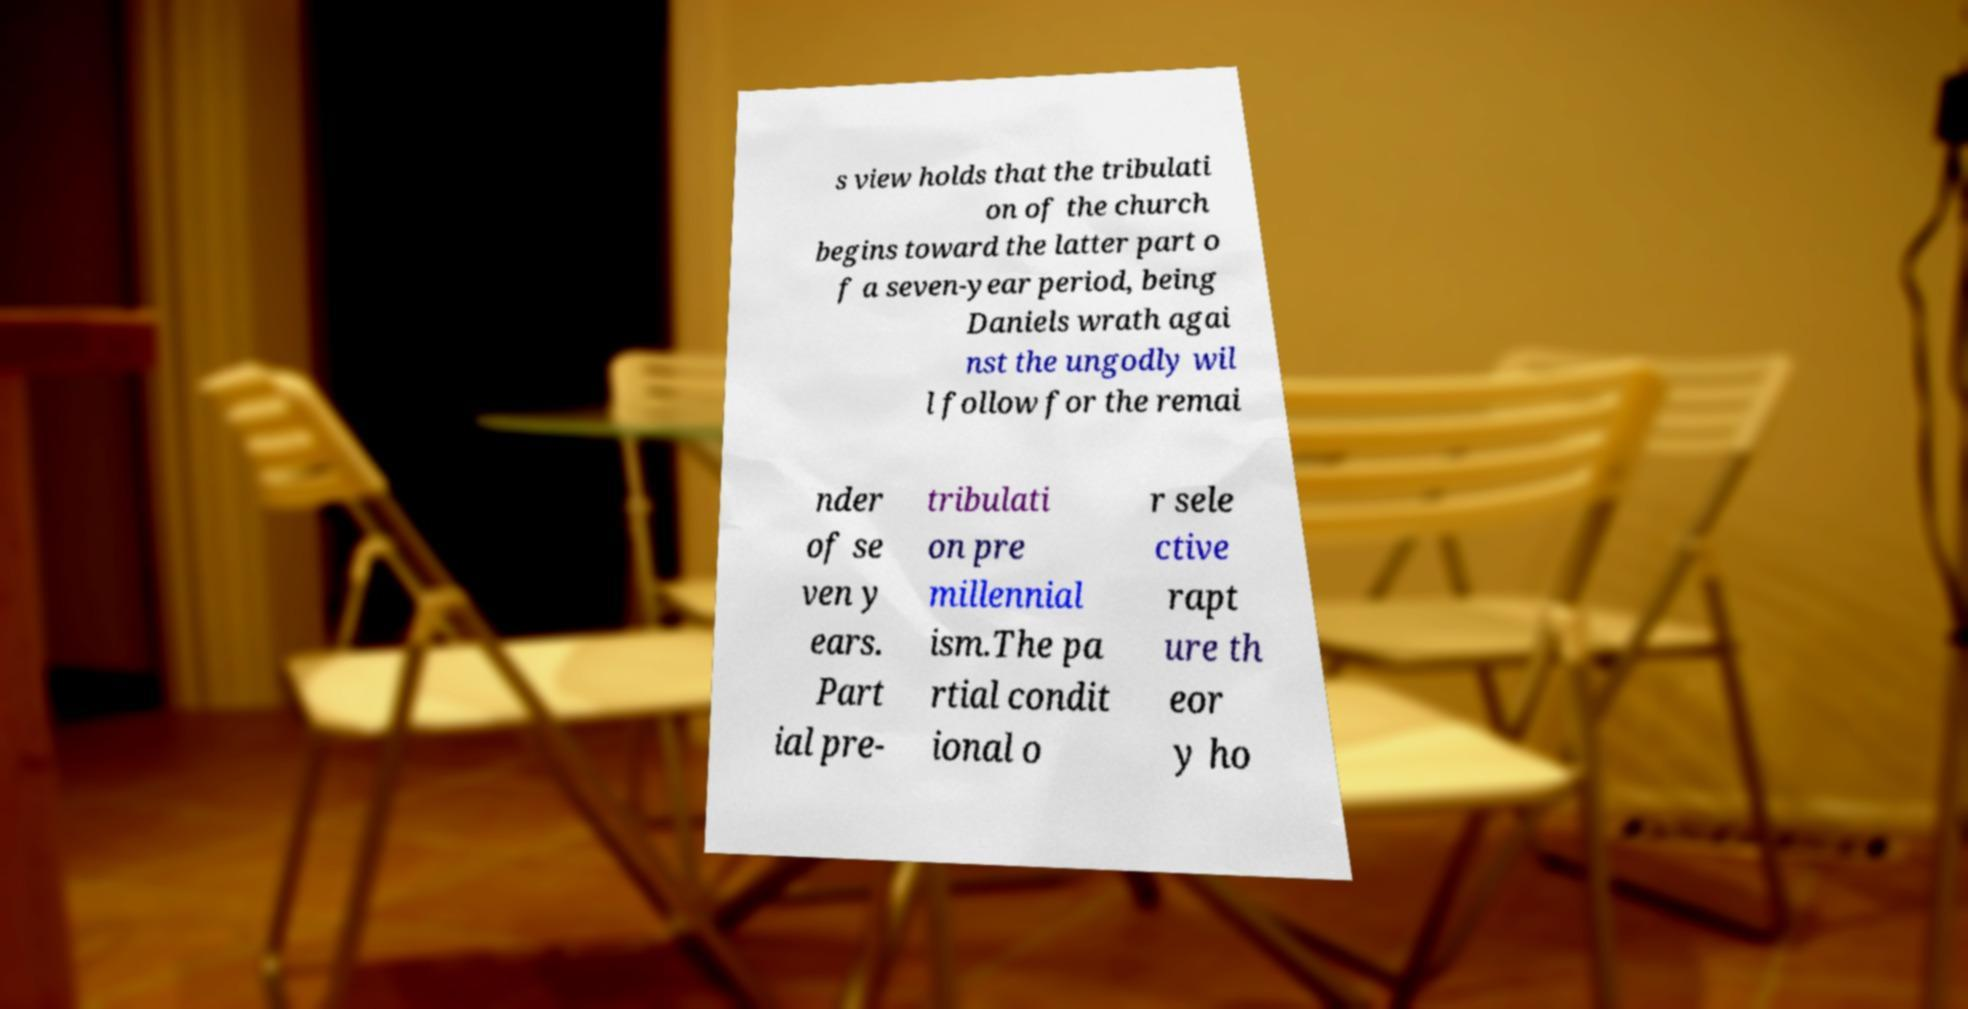What messages or text are displayed in this image? I need them in a readable, typed format. s view holds that the tribulati on of the church begins toward the latter part o f a seven-year period, being Daniels wrath agai nst the ungodly wil l follow for the remai nder of se ven y ears. Part ial pre- tribulati on pre millennial ism.The pa rtial condit ional o r sele ctive rapt ure th eor y ho 